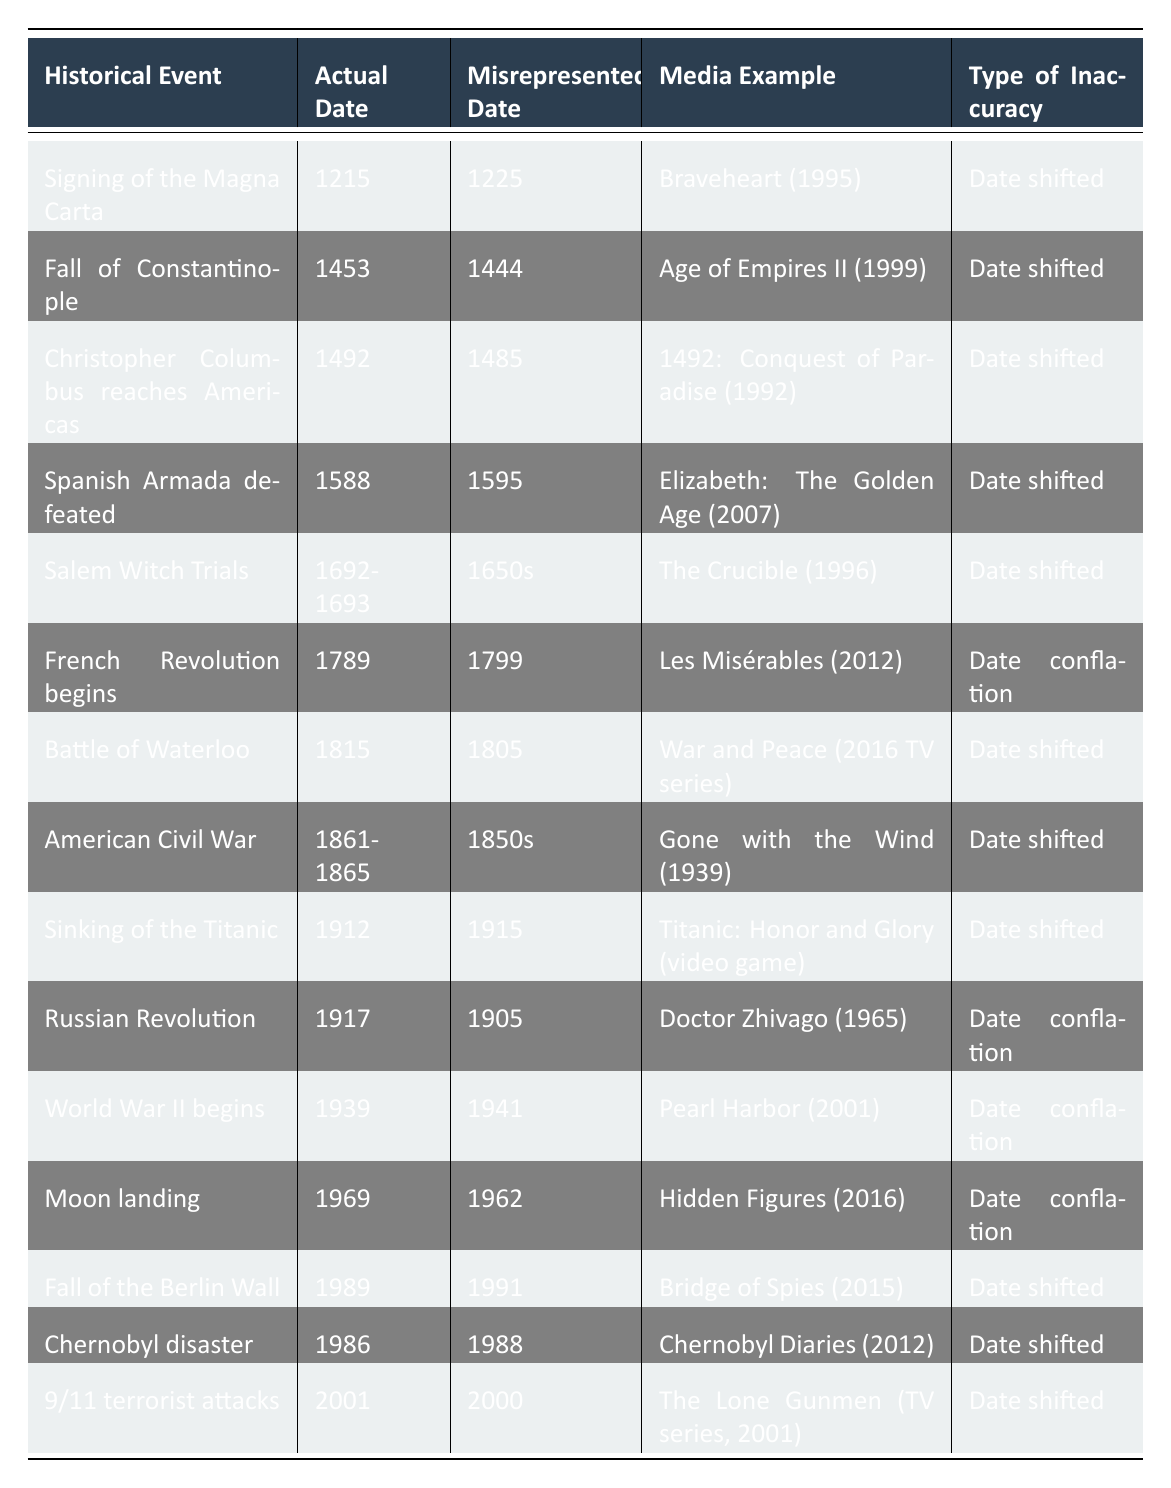What is the actual date of the signing of the Magna Carta? The table lists the actual date of the signing of the Magna Carta as 1215.
Answer: 1215 Which media example misrepresented the date of the French Revolution? According to the table, the media example that misrepresented the date of the French Revolution is "Les Misérables" (2012).
Answer: Les Misérables (2012) How many events have a misrepresented date due to a date shift? By examining the table, we can count the entries labeled with "Date shifted," which are 10 events.
Answer: 10 Was the Sinking of the Titanic depicted with a misrepresented date in the media? Yes, the Sinking of the Titanic has a misrepresented date of 1915 in the media example "Titanic: Honor and Glory."
Answer: Yes What is the difference between the actual date and the misrepresented date of the Spanish Armada defeat? The actual date is 1588 and the misrepresented date is 1595, a difference of 7 years.
Answer: 7 years Can you find any events that conflated the actual dates? If so, list them. The table shows three events that conflated the actual dates: the French Revolution, the Russian Revolution, and World War II.
Answer: Yes, three events Which event had its misrepresented date as the earliest in the list? The earliest event with a misrepresented date in the table is the signing of the Magna Carta, which is misrepresented as 1225.
Answer: Signing of the Magna Carta How many of the events listed occurred in the 20th century? From the table, we can identify five events that occurred in the 20th century: the sinking of the Titanic, the Russian Revolution, World War II, the Chernobyl disaster, and the 9/11 terrorist attacks.
Answer: 5 In which media example was the date of the American Civil War misrepresented? The media example that misrepresented the date of the American Civil War is "Gone with the Wind" (1939).
Answer: Gone with the Wind (1939) Was there any media that misrepresented the date of a historical event as occurring earlier than it actually did? Yes, “9/11 terrorist attacks” was misrepresented as occurring in 2000 instead of 2001.
Answer: Yes 